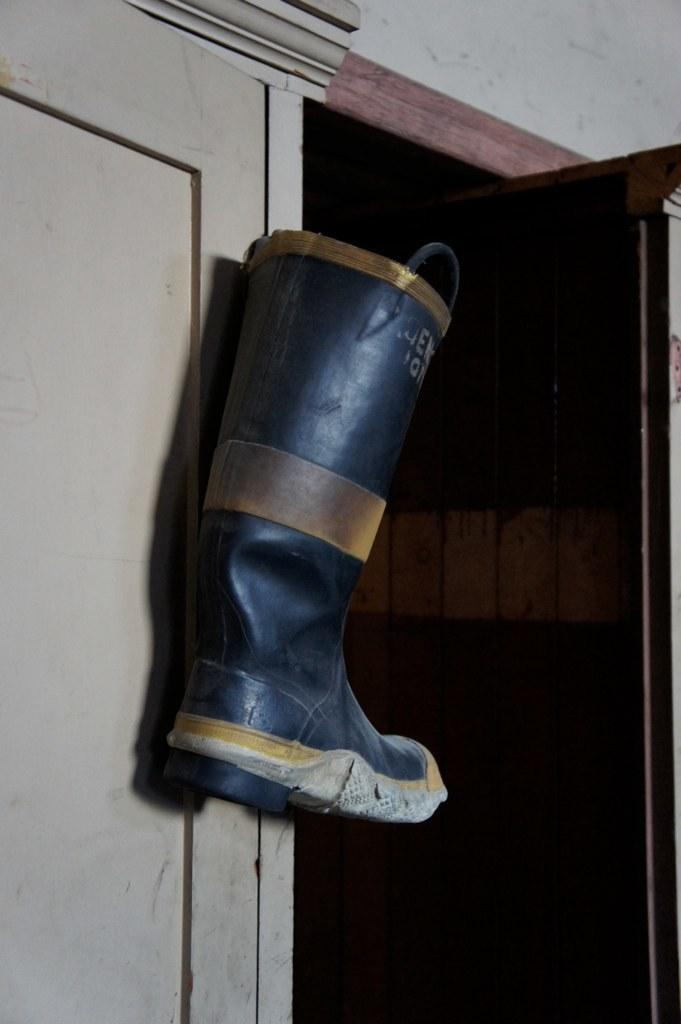What type of footwear is present in the image? There is a black color boot in the image. How is the boot positioned in the image? The boot is attached to a cupboard. What can be seen at the top of the image? There is a wall visible at the top of the image. What type of horn can be seen on the boot in the image? There is no horn present on the boot in the image. How many knots are tied on the boot in the image? The boot is attached to a cupboard, and there are no knots visible on it. 